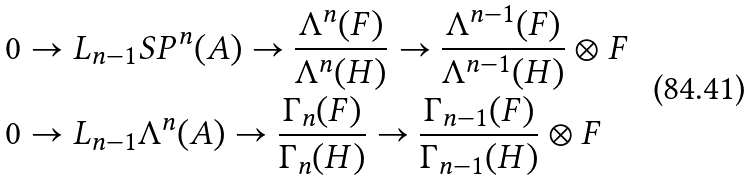Convert formula to latex. <formula><loc_0><loc_0><loc_500><loc_500>& 0 \to L _ { n - 1 } S P ^ { n } ( A ) \to \frac { \Lambda ^ { n } ( F ) } { \Lambda ^ { n } ( H ) } \to \frac { \Lambda ^ { n - 1 } ( F ) } { \Lambda ^ { n - 1 } ( H ) } \otimes F \\ & 0 \to L _ { n - 1 } \Lambda ^ { n } ( A ) \to \frac { \Gamma _ { n } ( F ) } { \Gamma _ { n } ( H ) } \to \frac { \Gamma _ { n - 1 } ( F ) } { \Gamma _ { n - 1 } ( H ) } \otimes F</formula> 